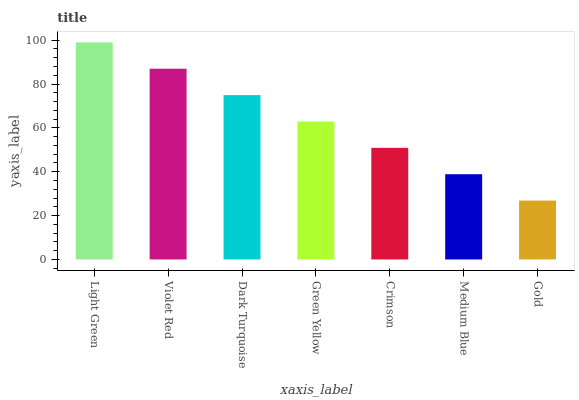Is Gold the minimum?
Answer yes or no. Yes. Is Light Green the maximum?
Answer yes or no. Yes. Is Violet Red the minimum?
Answer yes or no. No. Is Violet Red the maximum?
Answer yes or no. No. Is Light Green greater than Violet Red?
Answer yes or no. Yes. Is Violet Red less than Light Green?
Answer yes or no. Yes. Is Violet Red greater than Light Green?
Answer yes or no. No. Is Light Green less than Violet Red?
Answer yes or no. No. Is Green Yellow the high median?
Answer yes or no. Yes. Is Green Yellow the low median?
Answer yes or no. Yes. Is Violet Red the high median?
Answer yes or no. No. Is Gold the low median?
Answer yes or no. No. 